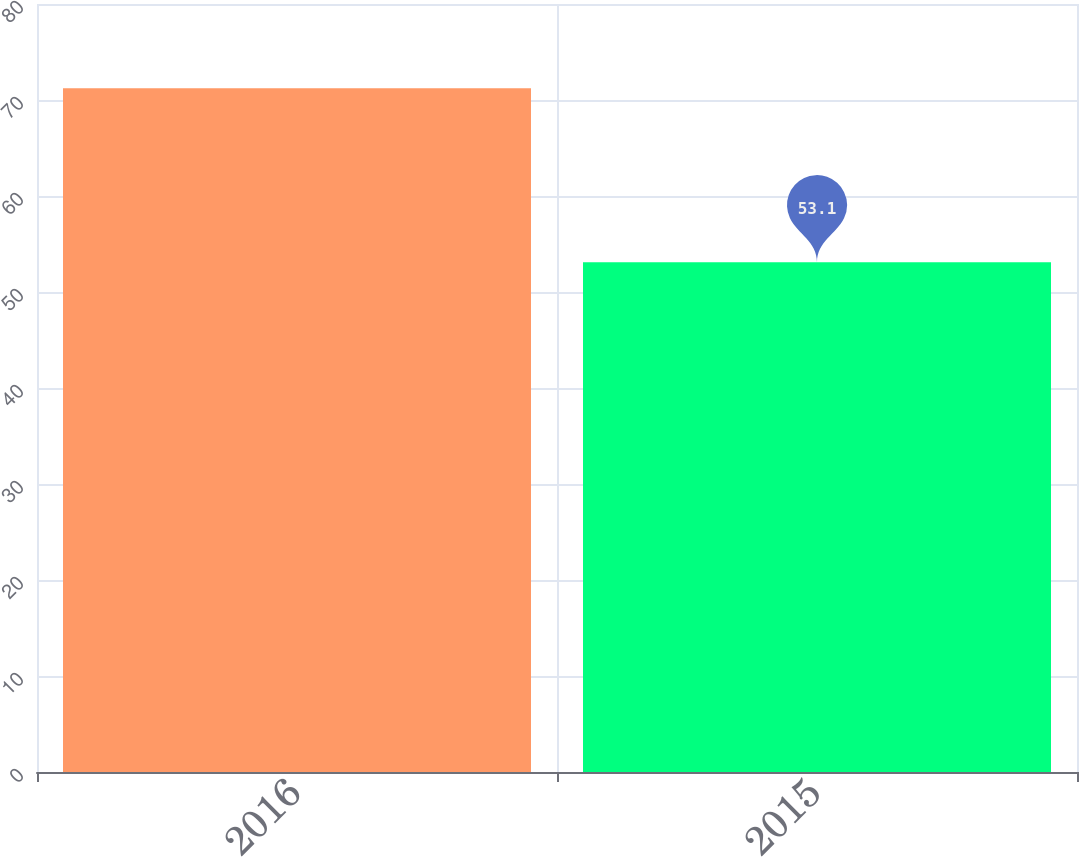Convert chart. <chart><loc_0><loc_0><loc_500><loc_500><bar_chart><fcel>2016<fcel>2015<nl><fcel>71.23<fcel>53.1<nl></chart> 